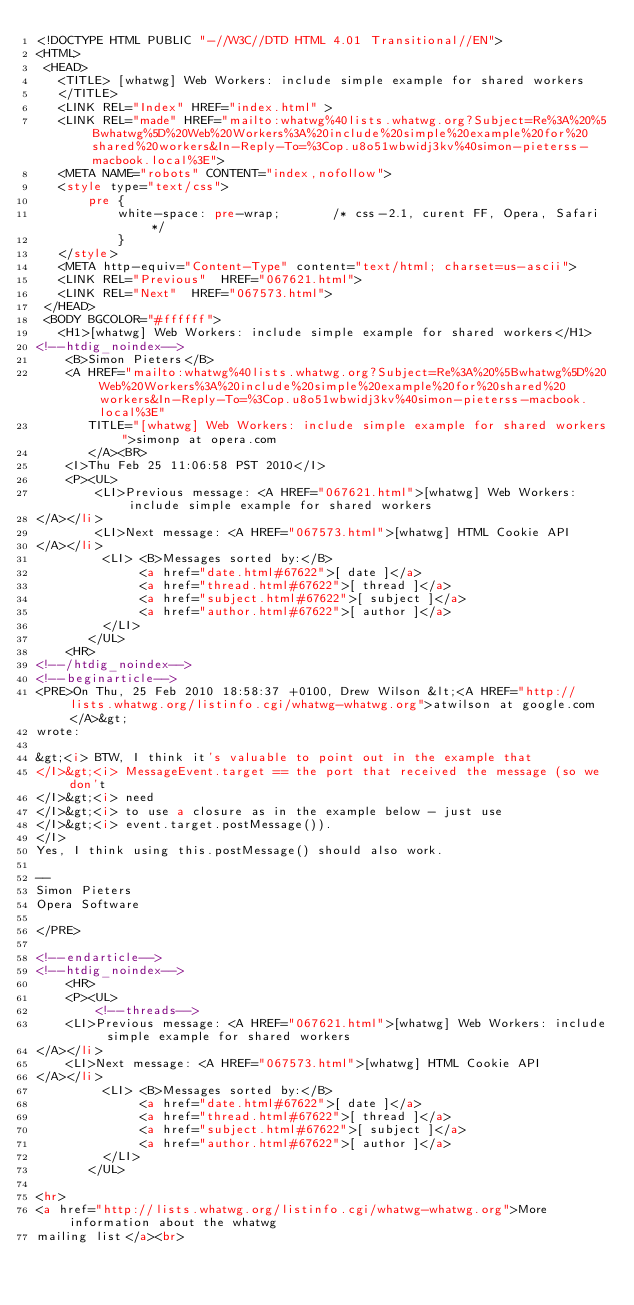Convert code to text. <code><loc_0><loc_0><loc_500><loc_500><_HTML_><!DOCTYPE HTML PUBLIC "-//W3C//DTD HTML 4.01 Transitional//EN">
<HTML>
 <HEAD>
   <TITLE> [whatwg] Web Workers: include simple example for shared workers
   </TITLE>
   <LINK REL="Index" HREF="index.html" >
   <LINK REL="made" HREF="mailto:whatwg%40lists.whatwg.org?Subject=Re%3A%20%5Bwhatwg%5D%20Web%20Workers%3A%20include%20simple%20example%20for%20shared%20workers&In-Reply-To=%3Cop.u8o51wbwidj3kv%40simon-pieterss-macbook.local%3E">
   <META NAME="robots" CONTENT="index,nofollow">
   <style type="text/css">
       pre {
           white-space: pre-wrap;       /* css-2.1, curent FF, Opera, Safari */
           }
   </style>
   <META http-equiv="Content-Type" content="text/html; charset=us-ascii">
   <LINK REL="Previous"  HREF="067621.html">
   <LINK REL="Next"  HREF="067573.html">
 </HEAD>
 <BODY BGCOLOR="#ffffff">
   <H1>[whatwg] Web Workers: include simple example for shared workers</H1>
<!--htdig_noindex-->
    <B>Simon Pieters</B> 
    <A HREF="mailto:whatwg%40lists.whatwg.org?Subject=Re%3A%20%5Bwhatwg%5D%20Web%20Workers%3A%20include%20simple%20example%20for%20shared%20workers&In-Reply-To=%3Cop.u8o51wbwidj3kv%40simon-pieterss-macbook.local%3E"
       TITLE="[whatwg] Web Workers: include simple example for shared workers">simonp at opera.com
       </A><BR>
    <I>Thu Feb 25 11:06:58 PST 2010</I>
    <P><UL>
        <LI>Previous message: <A HREF="067621.html">[whatwg] Web Workers: include simple example for shared workers
</A></li>
        <LI>Next message: <A HREF="067573.html">[whatwg] HTML Cookie API
</A></li>
         <LI> <B>Messages sorted by:</B> 
              <a href="date.html#67622">[ date ]</a>
              <a href="thread.html#67622">[ thread ]</a>
              <a href="subject.html#67622">[ subject ]</a>
              <a href="author.html#67622">[ author ]</a>
         </LI>
       </UL>
    <HR>  
<!--/htdig_noindex-->
<!--beginarticle-->
<PRE>On Thu, 25 Feb 2010 18:58:37 +0100, Drew Wilson &lt;<A HREF="http://lists.whatwg.org/listinfo.cgi/whatwg-whatwg.org">atwilson at google.com</A>&gt;  
wrote:

&gt;<i> BTW, I think it's valuable to point out in the example that
</I>&gt;<i> MessageEvent.target == the port that received the message (so we don't  
</I>&gt;<i> need
</I>&gt;<i> to use a closure as in the example below - just use
</I>&gt;<i> event.target.postMessage()).
</I>
Yes, I think using this.postMessage() should also work.

-- 
Simon Pieters
Opera Software

</PRE>

<!--endarticle-->
<!--htdig_noindex-->
    <HR>
    <P><UL>
        <!--threads-->
	<LI>Previous message: <A HREF="067621.html">[whatwg] Web Workers: include simple example for shared workers
</A></li>
	<LI>Next message: <A HREF="067573.html">[whatwg] HTML Cookie API
</A></li>
         <LI> <B>Messages sorted by:</B> 
              <a href="date.html#67622">[ date ]</a>
              <a href="thread.html#67622">[ thread ]</a>
              <a href="subject.html#67622">[ subject ]</a>
              <a href="author.html#67622">[ author ]</a>
         </LI>
       </UL>

<hr>
<a href="http://lists.whatwg.org/listinfo.cgi/whatwg-whatwg.org">More information about the whatwg
mailing list</a><br></code> 